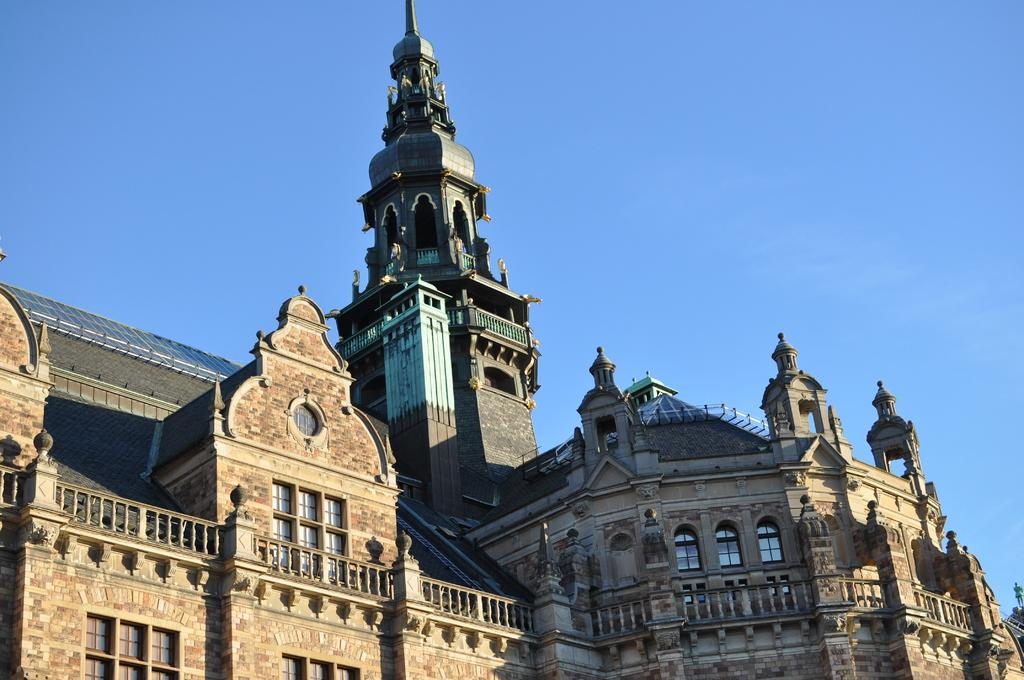What is the main structure in the image? There is a big fort in the image. What type of windows does the fort have? The fort has glass windows. What is visible at the top of the image? The sky is visible at the top of the image. What is the effect of the cough on the argument in the image? There is no cough or argument present in the image; it features a big fort with glass windows and a visible sky. 